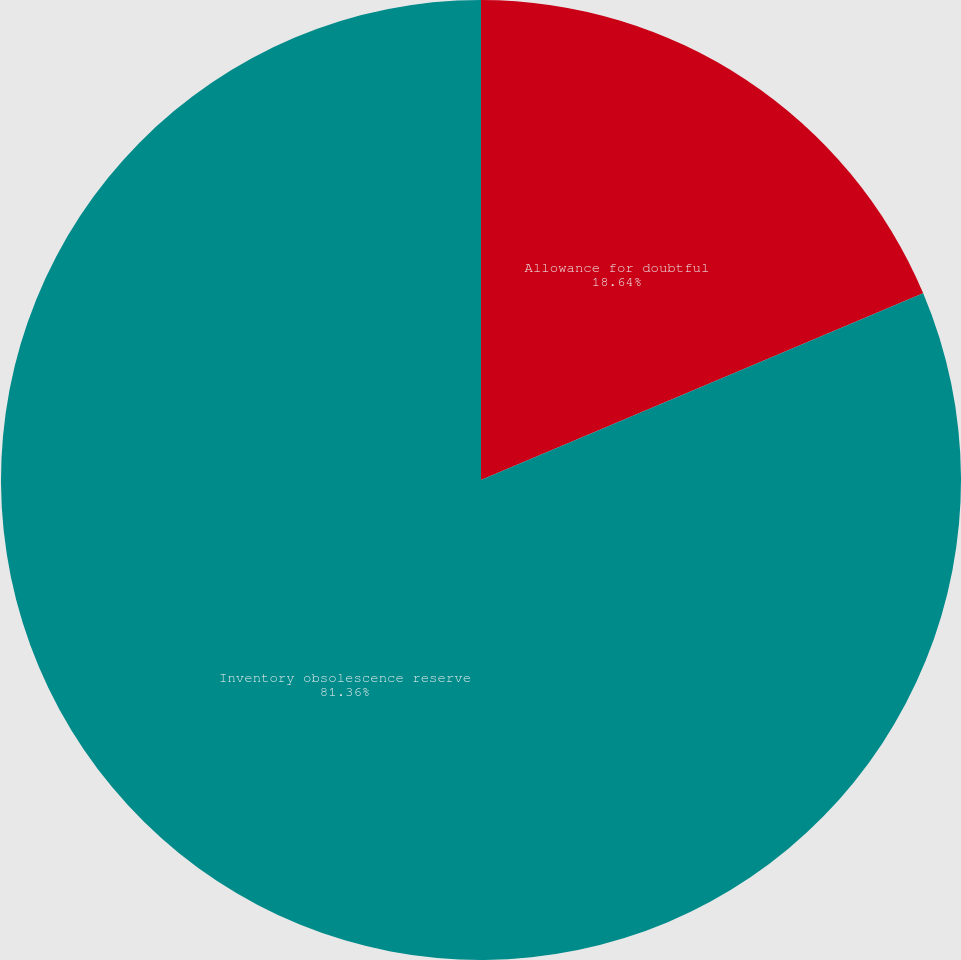Convert chart to OTSL. <chart><loc_0><loc_0><loc_500><loc_500><pie_chart><fcel>Allowance for doubtful<fcel>Inventory obsolescence reserve<nl><fcel>18.64%<fcel>81.36%<nl></chart> 